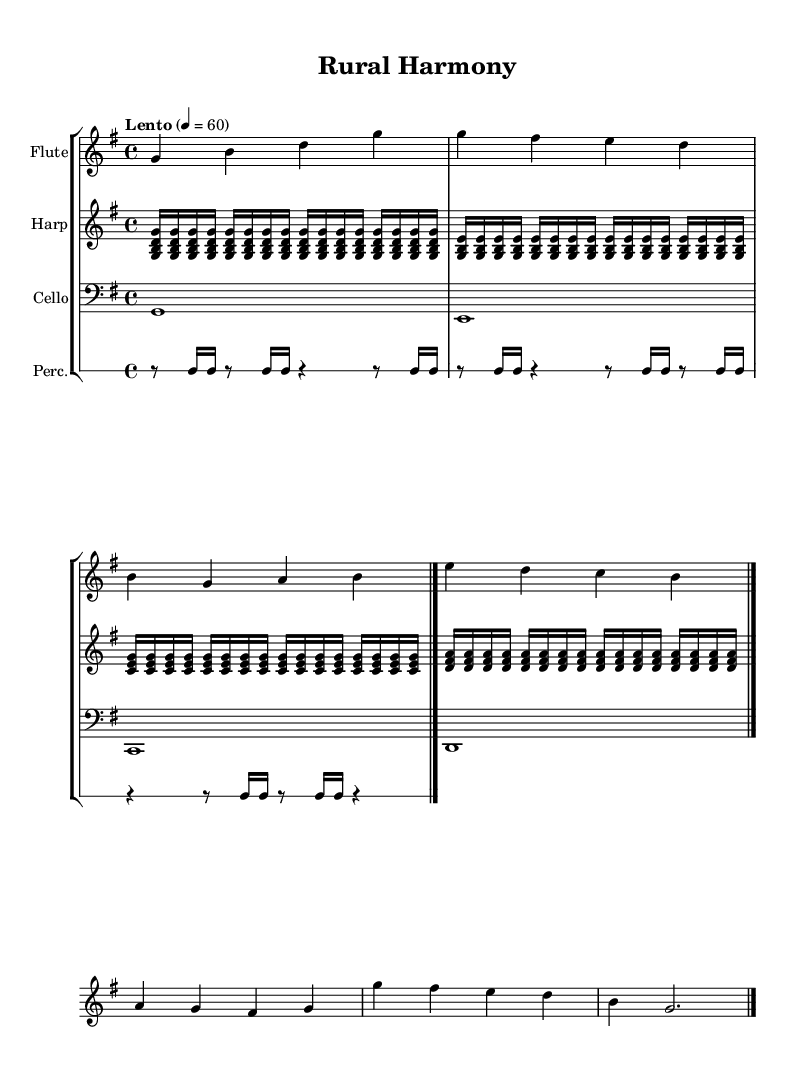What is the key signature of this music? The key signature is indicated at the beginning of the staff, showing one sharp. This indicates that the music is in G major.
Answer: G major What is the time signature of this music? The time signature is shown at the beginning of the score, which is 4/4. This means there are four beats in each measure and a quarter note gets one beat.
Answer: 4/4 What is the tempo marking for this piece? The tempo is indicated in a tempo marking at the start of the score, which states "Lento" and a metronome marking of 60 beats per minute, indicating the speed of the music.
Answer: Lento Which instruments are featured in this composition? Each instrument is labeled at the beginning of its respective staff. The labels read Flute, Harp, Cello, and Percussion, indicating the instruments used in this piece.
Answer: Flute, Harp, Cello, Percussion How many measures are in the Flute part? The Flute part is divided into distinct measures, and by counting, we see there are 8 measures shown before the final bar line.
Answer: 8 What type of sounds are represented in the rhythmic pattern of the percussion part? The rhythmic pattern in the percussion part consists of rests and notes in a sequence that resembles natural farm sounds, with a combination of eighth and sixteenth notes giving a lively rhythm.
Answer: Natural farm sounds Which note appears most frequently in the Harp part? By analyzing the Harp part, we can see that the note G appears consistently throughout the repeated arpeggios, making it the most frequently occurring note in that part.
Answer: G 